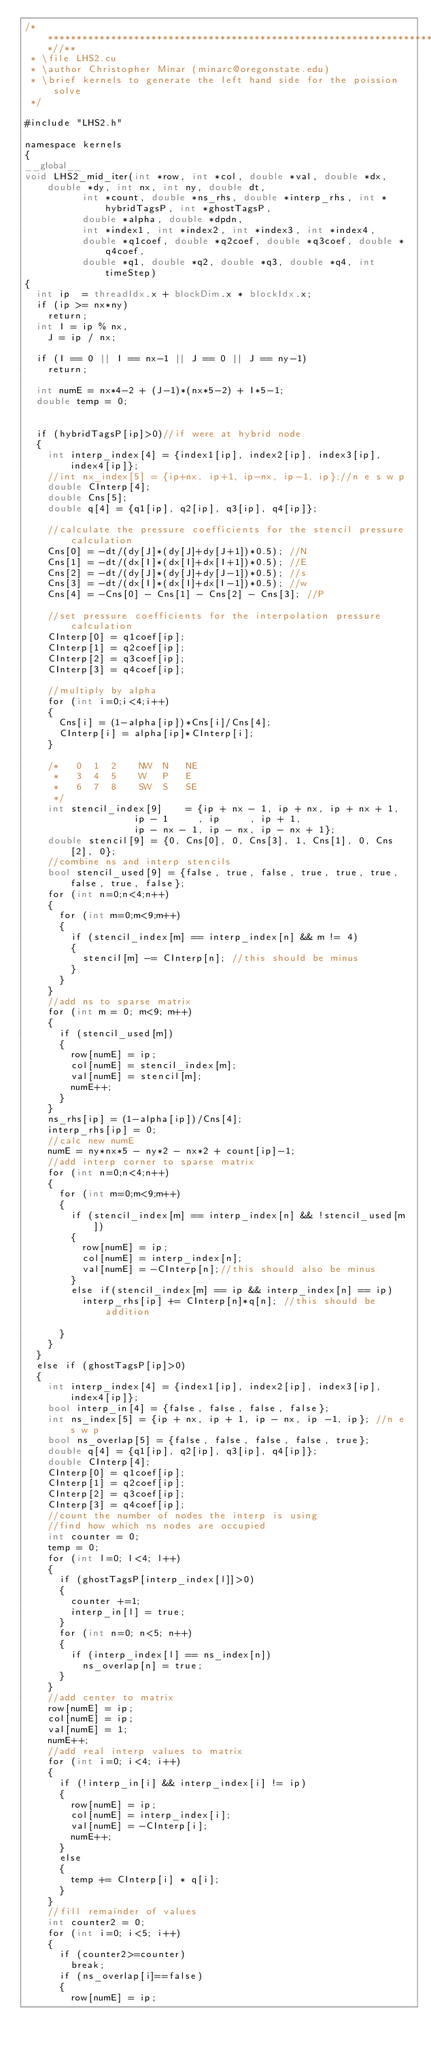<code> <loc_0><loc_0><loc_500><loc_500><_Cuda_>/***************************************************************************//**
 * \file LHS2.cu
 * \author Christopher Minar (minarc@oregonstate.edu)
 * \brief kernels to generate the left hand side for the poission solve
 */

#include "LHS2.h"

namespace kernels
{
__global__
void LHS2_mid_iter(int *row, int *col, double *val, double *dx, double *dy, int nx, int ny, double dt,
					int *count, double *ns_rhs, double *interp_rhs, int *hybridTagsP, int *ghostTagsP,
					double *alpha, double *dpdn,
					int *index1, int *index2, int *index3, int *index4,
					double *q1coef, double *q2coef, double *q3coef, double *q4coef,
					double *q1, double *q2, double *q3, double *q4, int timeStep)
{
	int ip 	= threadIdx.x + blockDim.x * blockIdx.x;
	if (ip >= nx*ny)
		return;
	int	I	= ip % nx,
		J	= ip / nx;

	if (I == 0 || I == nx-1 || J == 0 || J == ny-1)
		return;

	int numE = nx*4-2 + (J-1)*(nx*5-2) + I*5-1;
	double temp = 0;


	if (hybridTagsP[ip]>0)//if were at hybrid node
	{
		int interp_index[4] = {index1[ip], index2[ip], index3[ip], index4[ip]};
		//int nx_index[5] = {ip+nx, ip+1, ip-nx, ip-1, ip};//n e s w p
		double CInterp[4];
		double Cns[5];
		double q[4] = {q1[ip], q2[ip], q3[ip], q4[ip]};

		//calculate the pressure coefficients for the stencil pressure calculation
		Cns[0] = -dt/(dy[J]*(dy[J]+dy[J+1])*0.5); //N
		Cns[1] = -dt/(dx[I]*(dx[I]+dx[I+1])*0.5); //E
		Cns[2] = -dt/(dy[J]*(dy[J]+dy[J-1])*0.5); //s
		Cns[3] = -dt/(dx[I]*(dx[I]+dx[I-1])*0.5); //w
		Cns[4] = -Cns[0] - Cns[1] - Cns[2] - Cns[3]; //P

		//set pressure coefficients for the interpolation pressure calculation
		CInterp[0] = q1coef[ip];
		CInterp[1] = q2coef[ip];
		CInterp[2] = q3coef[ip];
		CInterp[3] = q4coef[ip];

		//multiply by alpha
		for (int i=0;i<4;i++)
		{
			Cns[i] = (1-alpha[ip])*Cns[i]/Cns[4];
			CInterp[i] = alpha[ip]*CInterp[i];
		}

		/*   0  1  2		NW  N   NE
		 *   3  4  5		W   P   E
		 *   6  7  8		SW  S   SE
		 */
		int stencil_index[9]    = {ip + nx - 1, ip + nx, ip + nx + 1,
								   ip - 1     , ip     , ip + 1,
								   ip - nx - 1, ip - nx, ip - nx + 1};
		double stencil[9] = {0, Cns[0], 0, Cns[3], 1, Cns[1], 0, Cns[2], 0};
		//combine ns and interp stencils
		bool stencil_used[9] = {false, true, false, true, true, true, false, true, false};
		for (int n=0;n<4;n++)
		{
			for (int m=0;m<9;m++)
			{
				if (stencil_index[m] == interp_index[n] && m != 4)
				{
					stencil[m] -= CInterp[n]; //this should be minus
				}
			}
		}
		//add ns to sparse matrix
		for (int m = 0; m<9; m++)
		{
			if (stencil_used[m])
			{
				row[numE] = ip;
				col[numE] = stencil_index[m];
				val[numE] = stencil[m];
				numE++;
			}
		}
		ns_rhs[ip] = (1-alpha[ip])/Cns[4];
		interp_rhs[ip] = 0;
		//calc new numE
		numE = ny*nx*5 - ny*2 - nx*2 + count[ip]-1;
		//add interp corner to sparse matrix
		for (int n=0;n<4;n++)
		{
			for (int m=0;m<9;m++)
			{
				if (stencil_index[m] == interp_index[n] && !stencil_used[m])
				{
					row[numE] = ip;
					col[numE] = interp_index[n];
					val[numE] = -CInterp[n];//this should also be minus
				}
				else if(stencil_index[m] == ip && interp_index[n] == ip)
					interp_rhs[ip] += CInterp[n]*q[n]; //this should be addition

			}
		}
	}
	else if (ghostTagsP[ip]>0)
	{
		int interp_index[4] = {index1[ip], index2[ip], index3[ip], index4[ip]};
		bool interp_in[4] = {false, false, false, false};
		int ns_index[5] = {ip + nx, ip + 1, ip - nx, ip -1, ip}; //n e s w p
		bool ns_overlap[5] = {false, false, false, false, true};
		double q[4] = {q1[ip], q2[ip], q3[ip], q4[ip]};
		double CInterp[4];
		CInterp[0] = q1coef[ip];
		CInterp[1] = q2coef[ip];
		CInterp[2] = q3coef[ip];
		CInterp[3] = q4coef[ip];
		//count the number of nodes the interp is using
		//find how which ns nodes are occupied
		int counter = 0;
		temp = 0;
		for (int l=0; l<4; l++)
		{
			if (ghostTagsP[interp_index[l]]>0)
			{
				counter +=1;
				interp_in[l] = true;
			}
			for (int n=0; n<5; n++)
			{
				if (interp_index[l] == ns_index[n])
					ns_overlap[n] = true;
			}
		}
		//add center to matrix
		row[numE] = ip;
		col[numE] = ip;
		val[numE] = 1;
		numE++;
		//add real interp values to matrix
		for (int i=0; i<4; i++)
		{
			if (!interp_in[i] && interp_index[i] != ip)
			{
				row[numE] = ip;
				col[numE] = interp_index[i];
				val[numE] = -CInterp[i];
				numE++;
			}
			else
			{
				temp += CInterp[i] * q[i];
			}
		}
		//fill remainder of values
		int counter2 = 0;
		for (int i=0; i<5; i++)
		{
			if (counter2>=counter)
				break;
			if (ns_overlap[i]==false)
			{
				row[numE] = ip;</code> 